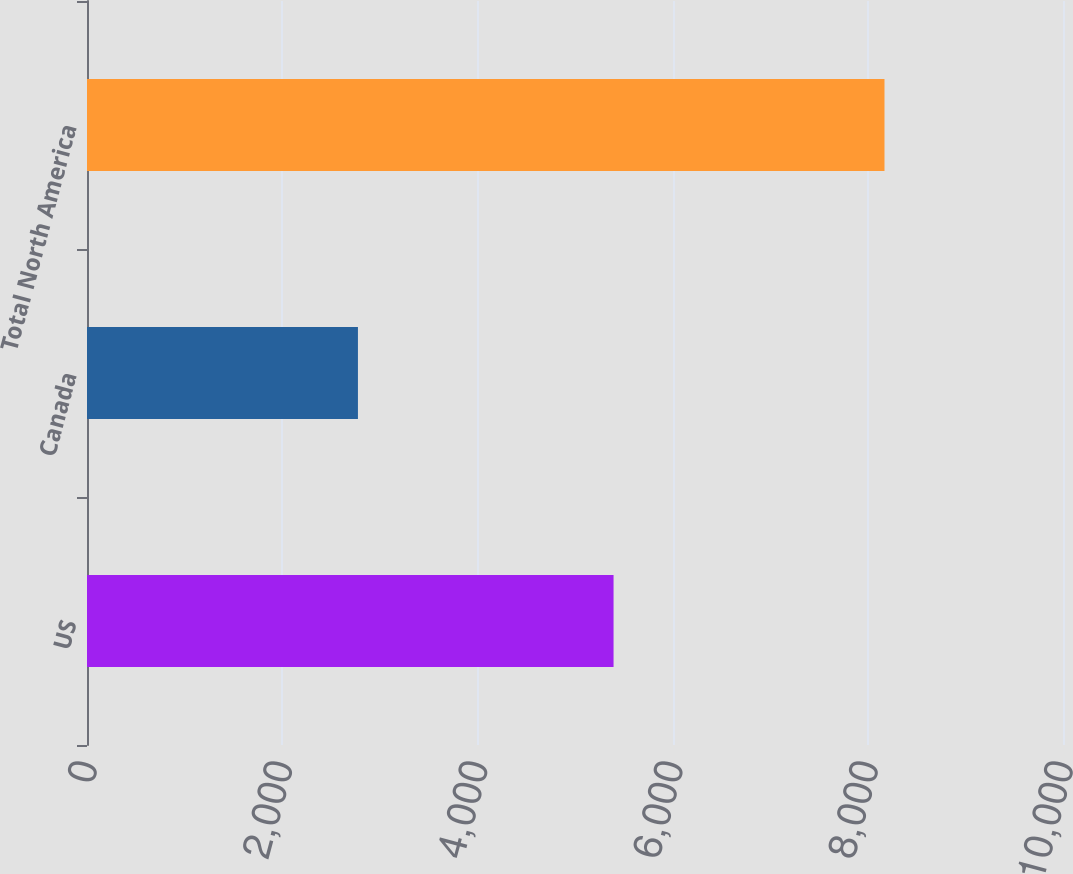Convert chart to OTSL. <chart><loc_0><loc_0><loc_500><loc_500><bar_chart><fcel>US<fcel>Canada<fcel>Total North America<nl><fcel>5395<fcel>2776<fcel>8171<nl></chart> 